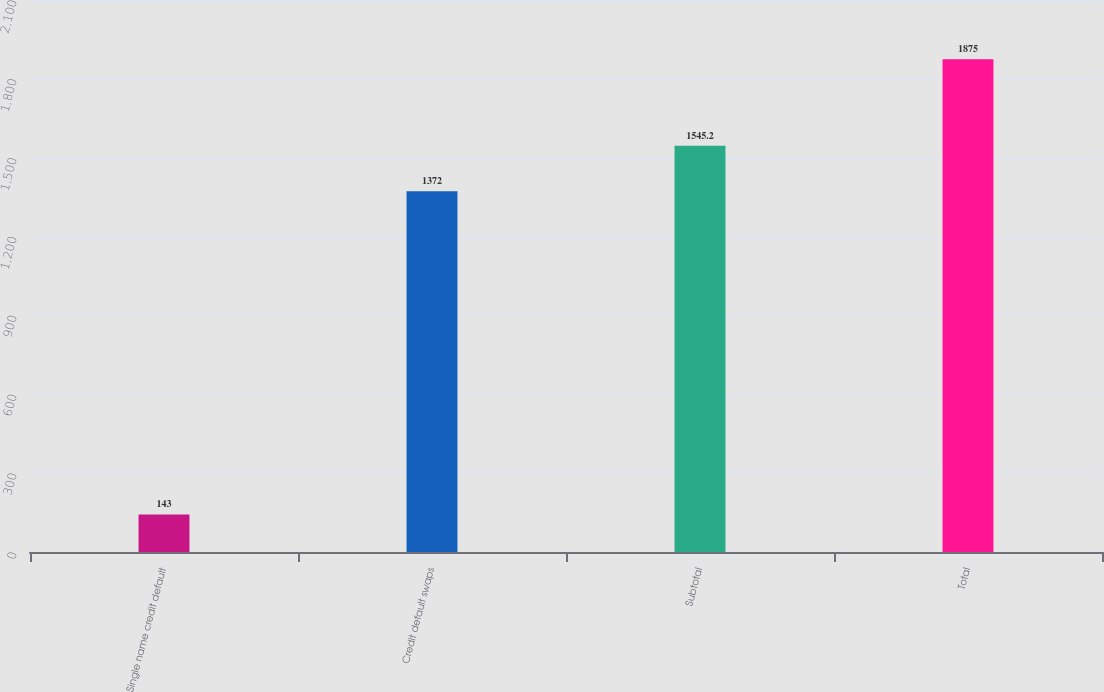<chart> <loc_0><loc_0><loc_500><loc_500><bar_chart><fcel>Single name credit default<fcel>Credit default swaps<fcel>Subtotal<fcel>Total<nl><fcel>143<fcel>1372<fcel>1545.2<fcel>1875<nl></chart> 